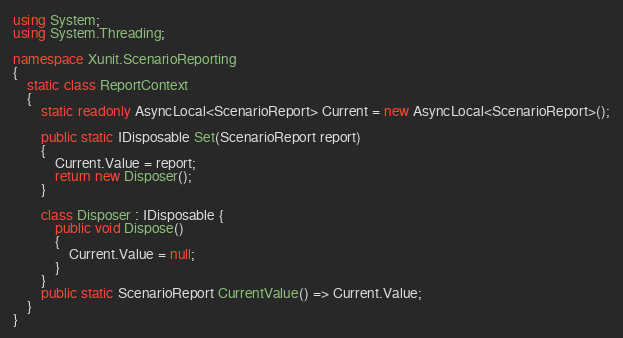Convert code to text. <code><loc_0><loc_0><loc_500><loc_500><_C#_>using System;
using System.Threading;

namespace Xunit.ScenarioReporting
{
    static class ReportContext
    {
        static readonly AsyncLocal<ScenarioReport> Current = new AsyncLocal<ScenarioReport>();

        public static IDisposable Set(ScenarioReport report)
        {
            Current.Value = report;
            return new Disposer();
        }

        class Disposer : IDisposable {
            public void Dispose()
            {
                Current.Value = null;
            }
        }
        public static ScenarioReport CurrentValue() => Current.Value;
    }
}</code> 